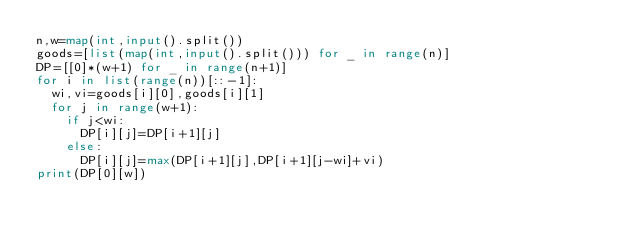Convert code to text. <code><loc_0><loc_0><loc_500><loc_500><_Python_>n,w=map(int,input().split())
goods=[list(map(int,input().split())) for _ in range(n)]
DP=[[0]*(w+1) for _ in range(n+1)]
for i in list(range(n))[::-1]:
  wi,vi=goods[i][0],goods[i][1]
  for j in range(w+1):
    if j<wi:
      DP[i][j]=DP[i+1][j]
    else:
      DP[i][j]=max(DP[i+1][j],DP[i+1][j-wi]+vi)
print(DP[0][w])
</code> 